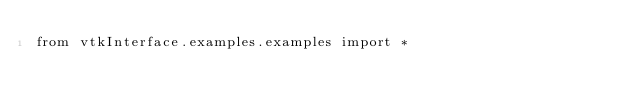Convert code to text. <code><loc_0><loc_0><loc_500><loc_500><_Python_>from vtkInterface.examples.examples import *</code> 